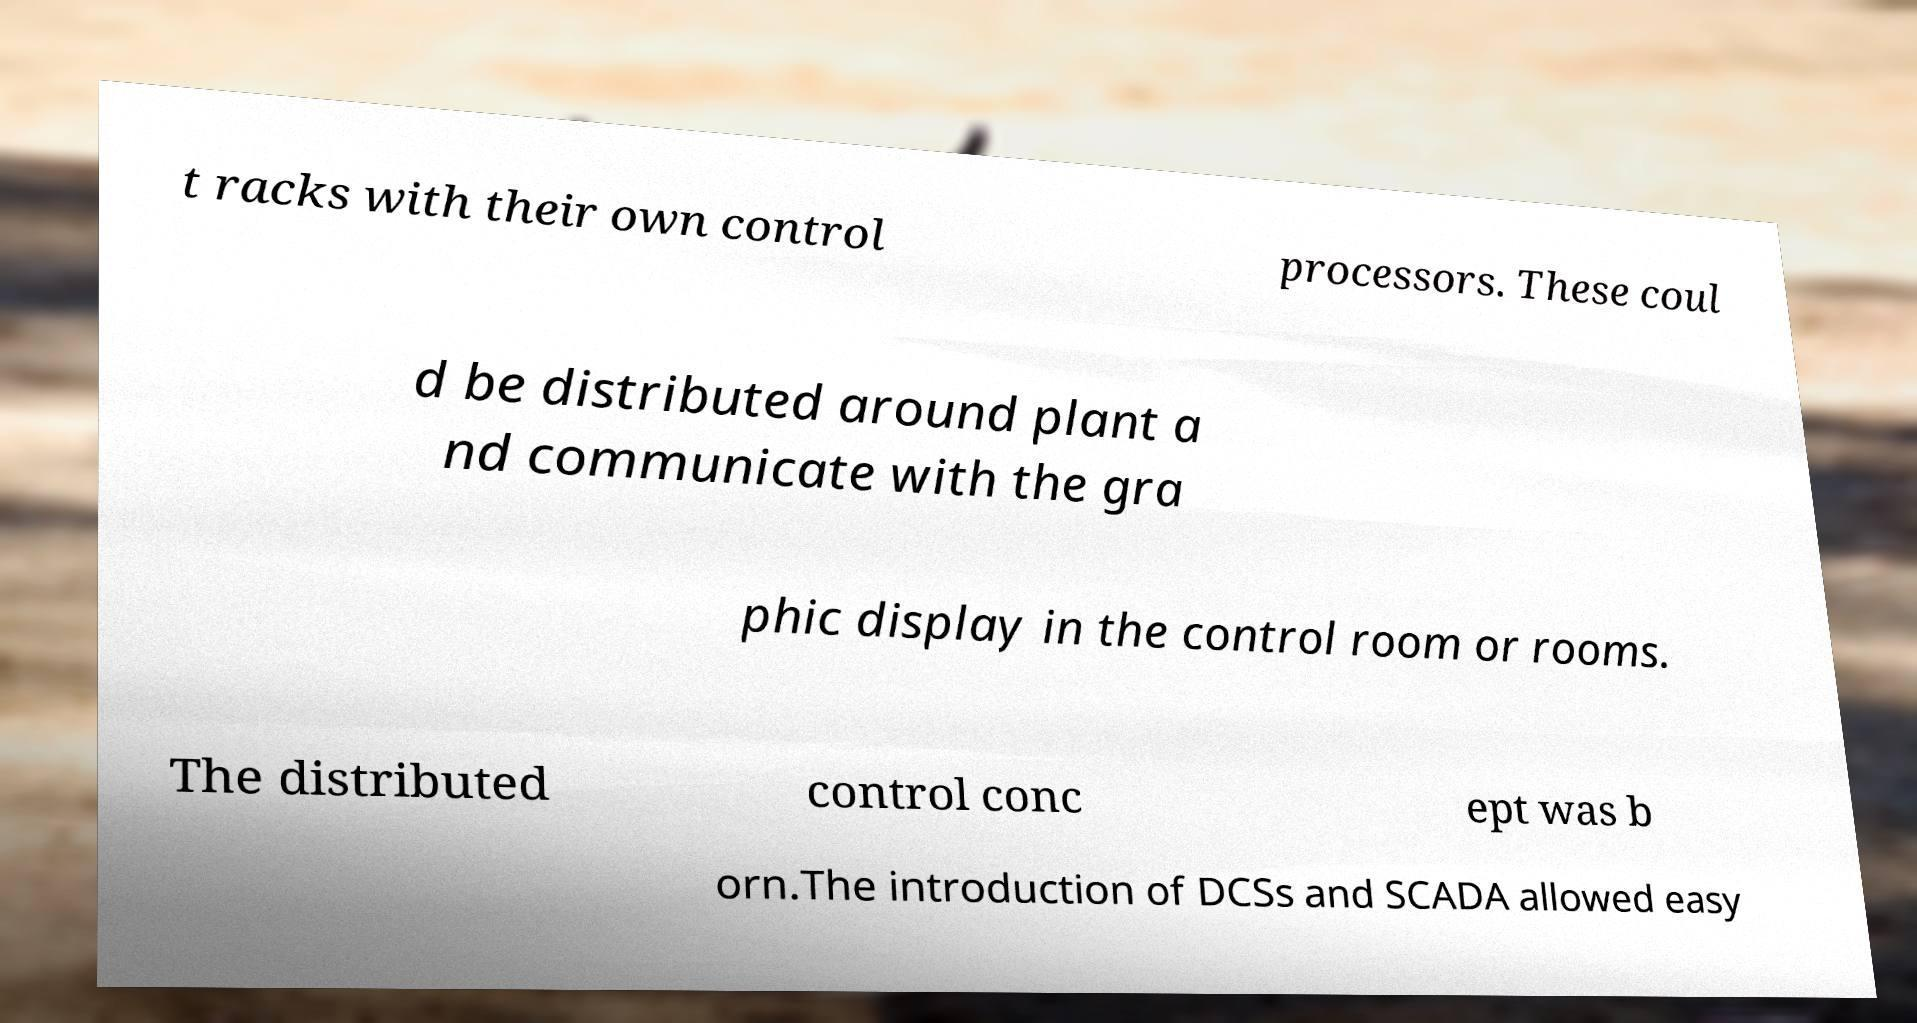I need the written content from this picture converted into text. Can you do that? t racks with their own control processors. These coul d be distributed around plant a nd communicate with the gra phic display in the control room or rooms. The distributed control conc ept was b orn.The introduction of DCSs and SCADA allowed easy 